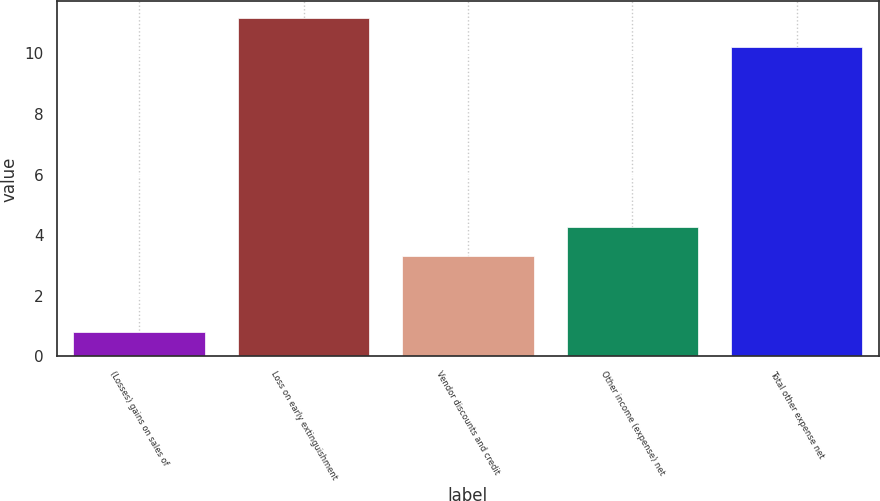Convert chart. <chart><loc_0><loc_0><loc_500><loc_500><bar_chart><fcel>(Losses) gains on sales of<fcel>Loss on early extinguishment<fcel>Vendor discounts and credit<fcel>Other income (expense) net<fcel>Total other expense net<nl><fcel>0.8<fcel>11.16<fcel>3.3<fcel>4.26<fcel>10.2<nl></chart> 